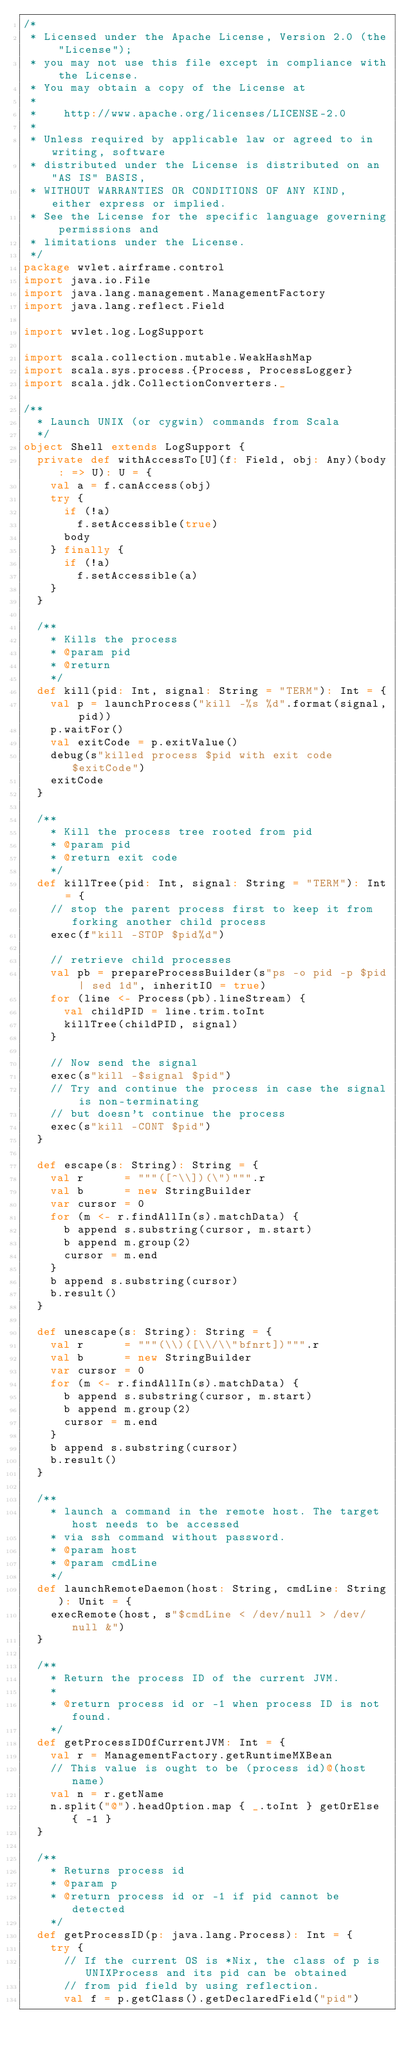<code> <loc_0><loc_0><loc_500><loc_500><_Scala_>/*
 * Licensed under the Apache License, Version 2.0 (the "License");
 * you may not use this file except in compliance with the License.
 * You may obtain a copy of the License at
 *
 *    http://www.apache.org/licenses/LICENSE-2.0
 *
 * Unless required by applicable law or agreed to in writing, software
 * distributed under the License is distributed on an "AS IS" BASIS,
 * WITHOUT WARRANTIES OR CONDITIONS OF ANY KIND, either express or implied.
 * See the License for the specific language governing permissions and
 * limitations under the License.
 */
package wvlet.airframe.control
import java.io.File
import java.lang.management.ManagementFactory
import java.lang.reflect.Field

import wvlet.log.LogSupport

import scala.collection.mutable.WeakHashMap
import scala.sys.process.{Process, ProcessLogger}
import scala.jdk.CollectionConverters._

/**
  * Launch UNIX (or cygwin) commands from Scala
  */
object Shell extends LogSupport {
  private def withAccessTo[U](f: Field, obj: Any)(body: => U): U = {
    val a = f.canAccess(obj)
    try {
      if (!a)
        f.setAccessible(true)
      body
    } finally {
      if (!a)
        f.setAccessible(a)
    }
  }

  /**
    * Kills the process
    * @param pid
    * @return
    */
  def kill(pid: Int, signal: String = "TERM"): Int = {
    val p = launchProcess("kill -%s %d".format(signal, pid))
    p.waitFor()
    val exitCode = p.exitValue()
    debug(s"killed process $pid with exit code $exitCode")
    exitCode
  }

  /**
    * Kill the process tree rooted from pid
    * @param pid
    * @return exit code
    */
  def killTree(pid: Int, signal: String = "TERM"): Int = {
    // stop the parent process first to keep it from forking another child process
    exec(f"kill -STOP $pid%d")

    // retrieve child processes
    val pb = prepareProcessBuilder(s"ps -o pid -p $pid | sed 1d", inheritIO = true)
    for (line <- Process(pb).lineStream) {
      val childPID = line.trim.toInt
      killTree(childPID, signal)
    }

    // Now send the signal
    exec(s"kill -$signal $pid")
    // Try and continue the process in case the signal is non-terminating
    // but doesn't continue the process
    exec(s"kill -CONT $pid")
  }

  def escape(s: String): String = {
    val r      = """([^\\])(\")""".r
    val b      = new StringBuilder
    var cursor = 0
    for (m <- r.findAllIn(s).matchData) {
      b append s.substring(cursor, m.start)
      b append m.group(2)
      cursor = m.end
    }
    b append s.substring(cursor)
    b.result()
  }

  def unescape(s: String): String = {
    val r      = """(\\)([\\/\\"bfnrt])""".r
    val b      = new StringBuilder
    var cursor = 0
    for (m <- r.findAllIn(s).matchData) {
      b append s.substring(cursor, m.start)
      b append m.group(2)
      cursor = m.end
    }
    b append s.substring(cursor)
    b.result()
  }

  /**
    * launch a command in the remote host. The target host needs to be accessed
    * via ssh command without password.
    * @param host
    * @param cmdLine
    */
  def launchRemoteDaemon(host: String, cmdLine: String): Unit = {
    execRemote(host, s"$cmdLine < /dev/null > /dev/null &")
  }

  /**
    * Return the process ID of the current JVM.
    *
    * @return process id or -1 when process ID is not found.
    */
  def getProcessIDOfCurrentJVM: Int = {
    val r = ManagementFactory.getRuntimeMXBean
    // This value is ought to be (process id)@(host name)
    val n = r.getName
    n.split("@").headOption.map { _.toInt } getOrElse { -1 }
  }

  /**
    * Returns process id
    * @param p
    * @return process id or -1 if pid cannot be detected
    */
  def getProcessID(p: java.lang.Process): Int = {
    try {
      // If the current OS is *Nix, the class of p is UNIXProcess and its pid can be obtained
      // from pid field by using reflection.
      val f = p.getClass().getDeclaredField("pid")</code> 